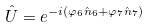<formula> <loc_0><loc_0><loc_500><loc_500>\hat { U } = e ^ { - i ( \varphi _ { 6 } \hat { n } _ { 6 } + \varphi _ { 7 } \hat { n } _ { 7 } ) }</formula> 